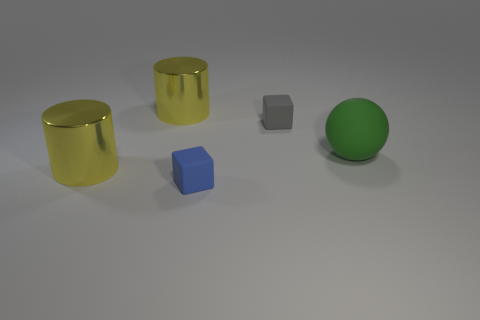Add 5 tiny yellow rubber things. How many objects exist? 10 Add 1 yellow objects. How many yellow objects are left? 3 Add 1 tiny gray cubes. How many tiny gray cubes exist? 2 Subtract 0 yellow balls. How many objects are left? 5 Subtract all blocks. How many objects are left? 3 Subtract all gray blocks. Subtract all blue spheres. How many blocks are left? 1 Subtract all gray balls. How many yellow blocks are left? 0 Subtract all rubber cubes. Subtract all big cylinders. How many objects are left? 1 